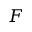Convert formula to latex. <formula><loc_0><loc_0><loc_500><loc_500>F</formula> 